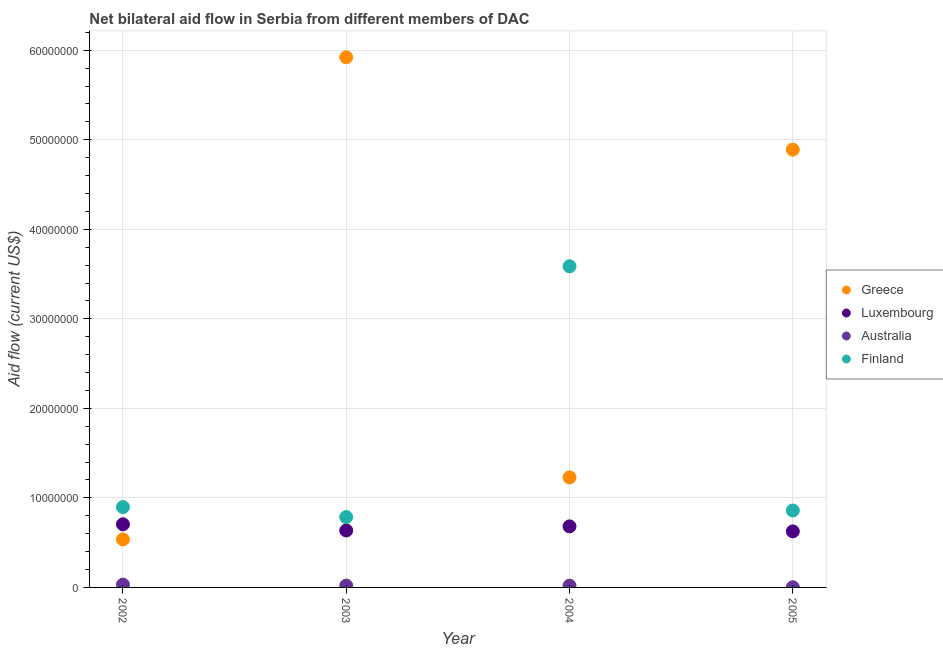How many different coloured dotlines are there?
Your response must be concise. 4. What is the amount of aid given by luxembourg in 2002?
Ensure brevity in your answer.  7.05e+06. Across all years, what is the maximum amount of aid given by finland?
Your response must be concise. 3.59e+07. Across all years, what is the minimum amount of aid given by luxembourg?
Provide a succinct answer. 6.26e+06. In which year was the amount of aid given by greece minimum?
Provide a short and direct response. 2002. What is the total amount of aid given by greece in the graph?
Ensure brevity in your answer.  1.26e+08. What is the difference between the amount of aid given by australia in 2004 and that in 2005?
Give a very brief answer. 1.70e+05. What is the difference between the amount of aid given by greece in 2003 and the amount of aid given by finland in 2004?
Your answer should be very brief. 2.33e+07. What is the average amount of aid given by finland per year?
Your answer should be very brief. 1.53e+07. In the year 2002, what is the difference between the amount of aid given by greece and amount of aid given by luxembourg?
Offer a very short reply. -1.69e+06. In how many years, is the amount of aid given by australia greater than 2000000 US$?
Make the answer very short. 0. What is the ratio of the amount of aid given by luxembourg in 2002 to that in 2003?
Provide a succinct answer. 1.11. Is the amount of aid given by australia in 2004 less than that in 2005?
Keep it short and to the point. No. What is the difference between the highest and the second highest amount of aid given by finland?
Your answer should be very brief. 2.69e+07. What is the difference between the highest and the lowest amount of aid given by finland?
Your answer should be compact. 2.80e+07. Is the sum of the amount of aid given by finland in 2004 and 2005 greater than the maximum amount of aid given by australia across all years?
Keep it short and to the point. Yes. Is it the case that in every year, the sum of the amount of aid given by greece and amount of aid given by luxembourg is greater than the amount of aid given by australia?
Provide a succinct answer. Yes. Is the amount of aid given by luxembourg strictly greater than the amount of aid given by finland over the years?
Your response must be concise. No. How many dotlines are there?
Provide a short and direct response. 4. What is the difference between two consecutive major ticks on the Y-axis?
Offer a very short reply. 1.00e+07. Are the values on the major ticks of Y-axis written in scientific E-notation?
Provide a short and direct response. No. Where does the legend appear in the graph?
Provide a succinct answer. Center right. How are the legend labels stacked?
Ensure brevity in your answer.  Vertical. What is the title of the graph?
Give a very brief answer. Net bilateral aid flow in Serbia from different members of DAC. What is the Aid flow (current US$) of Greece in 2002?
Your response must be concise. 5.36e+06. What is the Aid flow (current US$) of Luxembourg in 2002?
Your answer should be compact. 7.05e+06. What is the Aid flow (current US$) of Finland in 2002?
Offer a very short reply. 8.97e+06. What is the Aid flow (current US$) in Greece in 2003?
Ensure brevity in your answer.  5.92e+07. What is the Aid flow (current US$) of Luxembourg in 2003?
Your answer should be very brief. 6.36e+06. What is the Aid flow (current US$) of Finland in 2003?
Keep it short and to the point. 7.86e+06. What is the Aid flow (current US$) of Greece in 2004?
Ensure brevity in your answer.  1.23e+07. What is the Aid flow (current US$) of Luxembourg in 2004?
Your answer should be compact. 6.82e+06. What is the Aid flow (current US$) of Finland in 2004?
Provide a short and direct response. 3.59e+07. What is the Aid flow (current US$) of Greece in 2005?
Offer a terse response. 4.89e+07. What is the Aid flow (current US$) in Luxembourg in 2005?
Make the answer very short. 6.26e+06. What is the Aid flow (current US$) of Finland in 2005?
Offer a terse response. 8.59e+06. Across all years, what is the maximum Aid flow (current US$) in Greece?
Your response must be concise. 5.92e+07. Across all years, what is the maximum Aid flow (current US$) in Luxembourg?
Offer a terse response. 7.05e+06. Across all years, what is the maximum Aid flow (current US$) in Finland?
Your response must be concise. 3.59e+07. Across all years, what is the minimum Aid flow (current US$) of Greece?
Make the answer very short. 5.36e+06. Across all years, what is the minimum Aid flow (current US$) of Luxembourg?
Provide a short and direct response. 6.26e+06. Across all years, what is the minimum Aid flow (current US$) in Finland?
Provide a succinct answer. 7.86e+06. What is the total Aid flow (current US$) of Greece in the graph?
Your answer should be very brief. 1.26e+08. What is the total Aid flow (current US$) of Luxembourg in the graph?
Give a very brief answer. 2.65e+07. What is the total Aid flow (current US$) of Australia in the graph?
Offer a terse response. 7.20e+05. What is the total Aid flow (current US$) of Finland in the graph?
Offer a very short reply. 6.13e+07. What is the difference between the Aid flow (current US$) of Greece in 2002 and that in 2003?
Make the answer very short. -5.38e+07. What is the difference between the Aid flow (current US$) of Luxembourg in 2002 and that in 2003?
Your answer should be very brief. 6.90e+05. What is the difference between the Aid flow (current US$) in Australia in 2002 and that in 2003?
Make the answer very short. 1.10e+05. What is the difference between the Aid flow (current US$) in Finland in 2002 and that in 2003?
Make the answer very short. 1.11e+06. What is the difference between the Aid flow (current US$) in Greece in 2002 and that in 2004?
Make the answer very short. -6.93e+06. What is the difference between the Aid flow (current US$) of Australia in 2002 and that in 2004?
Provide a succinct answer. 1.20e+05. What is the difference between the Aid flow (current US$) in Finland in 2002 and that in 2004?
Your response must be concise. -2.69e+07. What is the difference between the Aid flow (current US$) of Greece in 2002 and that in 2005?
Give a very brief answer. -4.35e+07. What is the difference between the Aid flow (current US$) of Luxembourg in 2002 and that in 2005?
Keep it short and to the point. 7.90e+05. What is the difference between the Aid flow (current US$) of Greece in 2003 and that in 2004?
Provide a short and direct response. 4.69e+07. What is the difference between the Aid flow (current US$) of Luxembourg in 2003 and that in 2004?
Provide a short and direct response. -4.60e+05. What is the difference between the Aid flow (current US$) in Finland in 2003 and that in 2004?
Your answer should be very brief. -2.80e+07. What is the difference between the Aid flow (current US$) in Greece in 2003 and that in 2005?
Make the answer very short. 1.03e+07. What is the difference between the Aid flow (current US$) of Australia in 2003 and that in 2005?
Offer a terse response. 1.80e+05. What is the difference between the Aid flow (current US$) of Finland in 2003 and that in 2005?
Keep it short and to the point. -7.30e+05. What is the difference between the Aid flow (current US$) in Greece in 2004 and that in 2005?
Your response must be concise. -3.66e+07. What is the difference between the Aid flow (current US$) in Luxembourg in 2004 and that in 2005?
Provide a succinct answer. 5.60e+05. What is the difference between the Aid flow (current US$) in Australia in 2004 and that in 2005?
Provide a succinct answer. 1.70e+05. What is the difference between the Aid flow (current US$) of Finland in 2004 and that in 2005?
Give a very brief answer. 2.73e+07. What is the difference between the Aid flow (current US$) in Greece in 2002 and the Aid flow (current US$) in Luxembourg in 2003?
Give a very brief answer. -1.00e+06. What is the difference between the Aid flow (current US$) of Greece in 2002 and the Aid flow (current US$) of Australia in 2003?
Your answer should be very brief. 5.16e+06. What is the difference between the Aid flow (current US$) of Greece in 2002 and the Aid flow (current US$) of Finland in 2003?
Offer a very short reply. -2.50e+06. What is the difference between the Aid flow (current US$) of Luxembourg in 2002 and the Aid flow (current US$) of Australia in 2003?
Keep it short and to the point. 6.85e+06. What is the difference between the Aid flow (current US$) of Luxembourg in 2002 and the Aid flow (current US$) of Finland in 2003?
Your response must be concise. -8.10e+05. What is the difference between the Aid flow (current US$) in Australia in 2002 and the Aid flow (current US$) in Finland in 2003?
Ensure brevity in your answer.  -7.55e+06. What is the difference between the Aid flow (current US$) of Greece in 2002 and the Aid flow (current US$) of Luxembourg in 2004?
Provide a short and direct response. -1.46e+06. What is the difference between the Aid flow (current US$) in Greece in 2002 and the Aid flow (current US$) in Australia in 2004?
Make the answer very short. 5.17e+06. What is the difference between the Aid flow (current US$) of Greece in 2002 and the Aid flow (current US$) of Finland in 2004?
Make the answer very short. -3.05e+07. What is the difference between the Aid flow (current US$) of Luxembourg in 2002 and the Aid flow (current US$) of Australia in 2004?
Keep it short and to the point. 6.86e+06. What is the difference between the Aid flow (current US$) in Luxembourg in 2002 and the Aid flow (current US$) in Finland in 2004?
Provide a succinct answer. -2.88e+07. What is the difference between the Aid flow (current US$) of Australia in 2002 and the Aid flow (current US$) of Finland in 2004?
Provide a short and direct response. -3.56e+07. What is the difference between the Aid flow (current US$) in Greece in 2002 and the Aid flow (current US$) in Luxembourg in 2005?
Keep it short and to the point. -9.00e+05. What is the difference between the Aid flow (current US$) in Greece in 2002 and the Aid flow (current US$) in Australia in 2005?
Provide a succinct answer. 5.34e+06. What is the difference between the Aid flow (current US$) in Greece in 2002 and the Aid flow (current US$) in Finland in 2005?
Your answer should be very brief. -3.23e+06. What is the difference between the Aid flow (current US$) in Luxembourg in 2002 and the Aid flow (current US$) in Australia in 2005?
Your answer should be compact. 7.03e+06. What is the difference between the Aid flow (current US$) of Luxembourg in 2002 and the Aid flow (current US$) of Finland in 2005?
Your answer should be compact. -1.54e+06. What is the difference between the Aid flow (current US$) of Australia in 2002 and the Aid flow (current US$) of Finland in 2005?
Your answer should be compact. -8.28e+06. What is the difference between the Aid flow (current US$) in Greece in 2003 and the Aid flow (current US$) in Luxembourg in 2004?
Ensure brevity in your answer.  5.24e+07. What is the difference between the Aid flow (current US$) in Greece in 2003 and the Aid flow (current US$) in Australia in 2004?
Offer a very short reply. 5.90e+07. What is the difference between the Aid flow (current US$) of Greece in 2003 and the Aid flow (current US$) of Finland in 2004?
Make the answer very short. 2.33e+07. What is the difference between the Aid flow (current US$) in Luxembourg in 2003 and the Aid flow (current US$) in Australia in 2004?
Offer a very short reply. 6.17e+06. What is the difference between the Aid flow (current US$) in Luxembourg in 2003 and the Aid flow (current US$) in Finland in 2004?
Provide a short and direct response. -2.95e+07. What is the difference between the Aid flow (current US$) in Australia in 2003 and the Aid flow (current US$) in Finland in 2004?
Provide a succinct answer. -3.57e+07. What is the difference between the Aid flow (current US$) of Greece in 2003 and the Aid flow (current US$) of Luxembourg in 2005?
Keep it short and to the point. 5.30e+07. What is the difference between the Aid flow (current US$) of Greece in 2003 and the Aid flow (current US$) of Australia in 2005?
Give a very brief answer. 5.92e+07. What is the difference between the Aid flow (current US$) of Greece in 2003 and the Aid flow (current US$) of Finland in 2005?
Provide a succinct answer. 5.06e+07. What is the difference between the Aid flow (current US$) of Luxembourg in 2003 and the Aid flow (current US$) of Australia in 2005?
Make the answer very short. 6.34e+06. What is the difference between the Aid flow (current US$) in Luxembourg in 2003 and the Aid flow (current US$) in Finland in 2005?
Provide a short and direct response. -2.23e+06. What is the difference between the Aid flow (current US$) in Australia in 2003 and the Aid flow (current US$) in Finland in 2005?
Your answer should be very brief. -8.39e+06. What is the difference between the Aid flow (current US$) of Greece in 2004 and the Aid flow (current US$) of Luxembourg in 2005?
Your answer should be compact. 6.03e+06. What is the difference between the Aid flow (current US$) of Greece in 2004 and the Aid flow (current US$) of Australia in 2005?
Your answer should be very brief. 1.23e+07. What is the difference between the Aid flow (current US$) in Greece in 2004 and the Aid flow (current US$) in Finland in 2005?
Provide a short and direct response. 3.70e+06. What is the difference between the Aid flow (current US$) of Luxembourg in 2004 and the Aid flow (current US$) of Australia in 2005?
Give a very brief answer. 6.80e+06. What is the difference between the Aid flow (current US$) in Luxembourg in 2004 and the Aid flow (current US$) in Finland in 2005?
Your answer should be very brief. -1.77e+06. What is the difference between the Aid flow (current US$) of Australia in 2004 and the Aid flow (current US$) of Finland in 2005?
Provide a short and direct response. -8.40e+06. What is the average Aid flow (current US$) of Greece per year?
Your response must be concise. 3.14e+07. What is the average Aid flow (current US$) of Luxembourg per year?
Give a very brief answer. 6.62e+06. What is the average Aid flow (current US$) in Finland per year?
Provide a succinct answer. 1.53e+07. In the year 2002, what is the difference between the Aid flow (current US$) in Greece and Aid flow (current US$) in Luxembourg?
Keep it short and to the point. -1.69e+06. In the year 2002, what is the difference between the Aid flow (current US$) in Greece and Aid flow (current US$) in Australia?
Give a very brief answer. 5.05e+06. In the year 2002, what is the difference between the Aid flow (current US$) in Greece and Aid flow (current US$) in Finland?
Provide a short and direct response. -3.61e+06. In the year 2002, what is the difference between the Aid flow (current US$) in Luxembourg and Aid flow (current US$) in Australia?
Your answer should be compact. 6.74e+06. In the year 2002, what is the difference between the Aid flow (current US$) of Luxembourg and Aid flow (current US$) of Finland?
Your response must be concise. -1.92e+06. In the year 2002, what is the difference between the Aid flow (current US$) of Australia and Aid flow (current US$) of Finland?
Your answer should be compact. -8.66e+06. In the year 2003, what is the difference between the Aid flow (current US$) in Greece and Aid flow (current US$) in Luxembourg?
Provide a succinct answer. 5.28e+07. In the year 2003, what is the difference between the Aid flow (current US$) of Greece and Aid flow (current US$) of Australia?
Keep it short and to the point. 5.90e+07. In the year 2003, what is the difference between the Aid flow (current US$) in Greece and Aid flow (current US$) in Finland?
Offer a very short reply. 5.14e+07. In the year 2003, what is the difference between the Aid flow (current US$) of Luxembourg and Aid flow (current US$) of Australia?
Offer a terse response. 6.16e+06. In the year 2003, what is the difference between the Aid flow (current US$) of Luxembourg and Aid flow (current US$) of Finland?
Ensure brevity in your answer.  -1.50e+06. In the year 2003, what is the difference between the Aid flow (current US$) in Australia and Aid flow (current US$) in Finland?
Provide a succinct answer. -7.66e+06. In the year 2004, what is the difference between the Aid flow (current US$) in Greece and Aid flow (current US$) in Luxembourg?
Your response must be concise. 5.47e+06. In the year 2004, what is the difference between the Aid flow (current US$) of Greece and Aid flow (current US$) of Australia?
Provide a short and direct response. 1.21e+07. In the year 2004, what is the difference between the Aid flow (current US$) in Greece and Aid flow (current US$) in Finland?
Ensure brevity in your answer.  -2.36e+07. In the year 2004, what is the difference between the Aid flow (current US$) in Luxembourg and Aid flow (current US$) in Australia?
Make the answer very short. 6.63e+06. In the year 2004, what is the difference between the Aid flow (current US$) of Luxembourg and Aid flow (current US$) of Finland?
Your answer should be very brief. -2.90e+07. In the year 2004, what is the difference between the Aid flow (current US$) of Australia and Aid flow (current US$) of Finland?
Ensure brevity in your answer.  -3.57e+07. In the year 2005, what is the difference between the Aid flow (current US$) of Greece and Aid flow (current US$) of Luxembourg?
Offer a terse response. 4.26e+07. In the year 2005, what is the difference between the Aid flow (current US$) of Greece and Aid flow (current US$) of Australia?
Provide a succinct answer. 4.89e+07. In the year 2005, what is the difference between the Aid flow (current US$) in Greece and Aid flow (current US$) in Finland?
Your answer should be compact. 4.03e+07. In the year 2005, what is the difference between the Aid flow (current US$) in Luxembourg and Aid flow (current US$) in Australia?
Provide a succinct answer. 6.24e+06. In the year 2005, what is the difference between the Aid flow (current US$) of Luxembourg and Aid flow (current US$) of Finland?
Offer a very short reply. -2.33e+06. In the year 2005, what is the difference between the Aid flow (current US$) in Australia and Aid flow (current US$) in Finland?
Provide a succinct answer. -8.57e+06. What is the ratio of the Aid flow (current US$) of Greece in 2002 to that in 2003?
Keep it short and to the point. 0.09. What is the ratio of the Aid flow (current US$) in Luxembourg in 2002 to that in 2003?
Offer a very short reply. 1.11. What is the ratio of the Aid flow (current US$) in Australia in 2002 to that in 2003?
Ensure brevity in your answer.  1.55. What is the ratio of the Aid flow (current US$) in Finland in 2002 to that in 2003?
Provide a succinct answer. 1.14. What is the ratio of the Aid flow (current US$) in Greece in 2002 to that in 2004?
Your response must be concise. 0.44. What is the ratio of the Aid flow (current US$) in Luxembourg in 2002 to that in 2004?
Offer a terse response. 1.03. What is the ratio of the Aid flow (current US$) of Australia in 2002 to that in 2004?
Offer a very short reply. 1.63. What is the ratio of the Aid flow (current US$) in Finland in 2002 to that in 2004?
Provide a succinct answer. 0.25. What is the ratio of the Aid flow (current US$) in Greece in 2002 to that in 2005?
Your answer should be very brief. 0.11. What is the ratio of the Aid flow (current US$) in Luxembourg in 2002 to that in 2005?
Give a very brief answer. 1.13. What is the ratio of the Aid flow (current US$) in Australia in 2002 to that in 2005?
Your response must be concise. 15.5. What is the ratio of the Aid flow (current US$) of Finland in 2002 to that in 2005?
Your response must be concise. 1.04. What is the ratio of the Aid flow (current US$) in Greece in 2003 to that in 2004?
Provide a succinct answer. 4.82. What is the ratio of the Aid flow (current US$) of Luxembourg in 2003 to that in 2004?
Your answer should be compact. 0.93. What is the ratio of the Aid flow (current US$) in Australia in 2003 to that in 2004?
Give a very brief answer. 1.05. What is the ratio of the Aid flow (current US$) in Finland in 2003 to that in 2004?
Ensure brevity in your answer.  0.22. What is the ratio of the Aid flow (current US$) of Greece in 2003 to that in 2005?
Ensure brevity in your answer.  1.21. What is the ratio of the Aid flow (current US$) in Luxembourg in 2003 to that in 2005?
Offer a very short reply. 1.02. What is the ratio of the Aid flow (current US$) in Finland in 2003 to that in 2005?
Offer a very short reply. 0.92. What is the ratio of the Aid flow (current US$) in Greece in 2004 to that in 2005?
Provide a succinct answer. 0.25. What is the ratio of the Aid flow (current US$) of Luxembourg in 2004 to that in 2005?
Offer a very short reply. 1.09. What is the ratio of the Aid flow (current US$) of Australia in 2004 to that in 2005?
Provide a short and direct response. 9.5. What is the ratio of the Aid flow (current US$) in Finland in 2004 to that in 2005?
Your answer should be very brief. 4.18. What is the difference between the highest and the second highest Aid flow (current US$) of Greece?
Keep it short and to the point. 1.03e+07. What is the difference between the highest and the second highest Aid flow (current US$) in Australia?
Keep it short and to the point. 1.10e+05. What is the difference between the highest and the second highest Aid flow (current US$) in Finland?
Your response must be concise. 2.69e+07. What is the difference between the highest and the lowest Aid flow (current US$) in Greece?
Ensure brevity in your answer.  5.38e+07. What is the difference between the highest and the lowest Aid flow (current US$) in Luxembourg?
Offer a very short reply. 7.90e+05. What is the difference between the highest and the lowest Aid flow (current US$) of Australia?
Your answer should be compact. 2.90e+05. What is the difference between the highest and the lowest Aid flow (current US$) of Finland?
Your answer should be compact. 2.80e+07. 